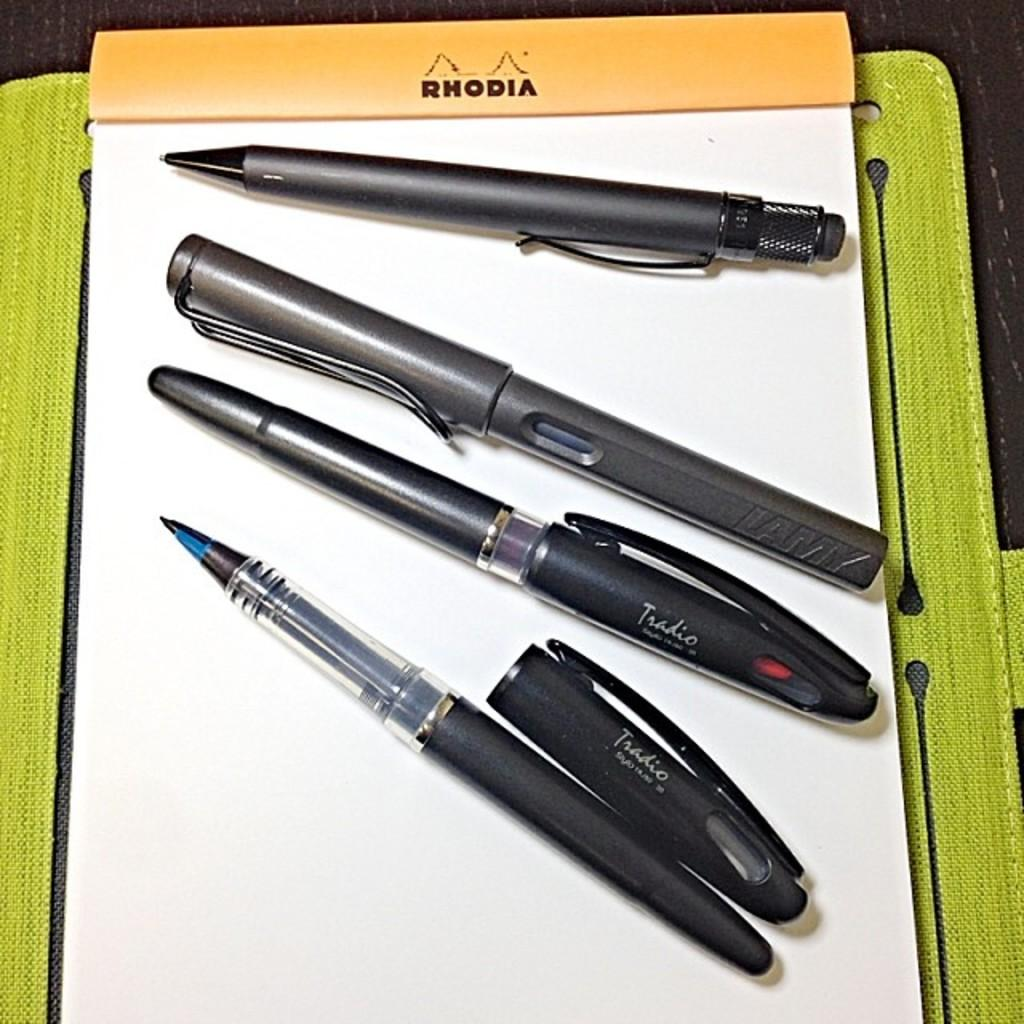What writing instruments are visible in the image? There are pens in the image. What type of object contains text in the image? There is a book with text in the image. Can you describe the color of any object in the image? Yes, there is an object that is green in color. What type of root can be seen growing from the book in the image? There is no root growing from the book in the image; it is a book with text and no roots are present. 